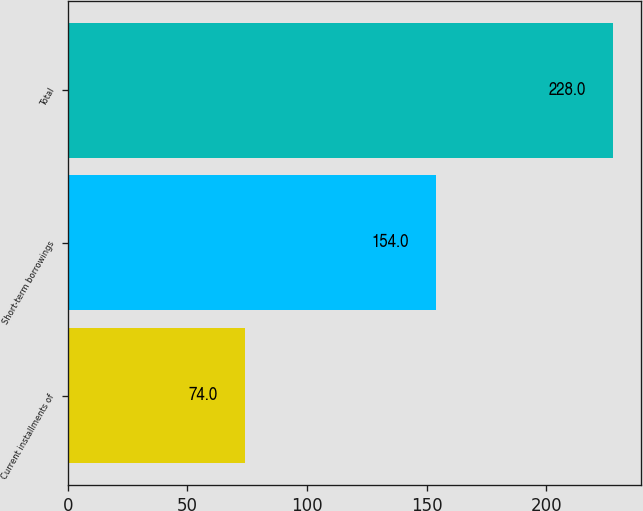Convert chart. <chart><loc_0><loc_0><loc_500><loc_500><bar_chart><fcel>Current installments of<fcel>Short-term borrowings<fcel>Total<nl><fcel>74<fcel>154<fcel>228<nl></chart> 